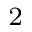Convert formula to latex. <formula><loc_0><loc_0><loc_500><loc_500>^ { 2 }</formula> 